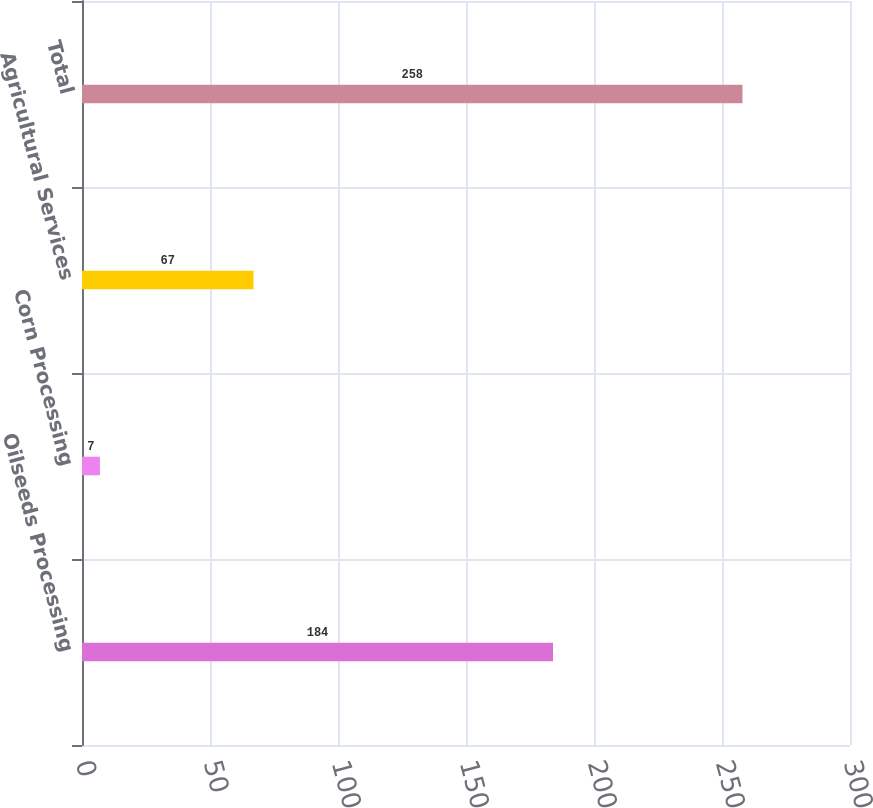Convert chart. <chart><loc_0><loc_0><loc_500><loc_500><bar_chart><fcel>Oilseeds Processing<fcel>Corn Processing<fcel>Agricultural Services<fcel>Total<nl><fcel>184<fcel>7<fcel>67<fcel>258<nl></chart> 